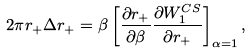Convert formula to latex. <formula><loc_0><loc_0><loc_500><loc_500>2 \pi r _ { + } \Delta r _ { + } = \beta \left [ { \frac { \partial { r _ { + } } } { \partial \beta } } { \frac { \partial { W _ { 1 } ^ { C S } } } { \partial r _ { + } } } \right ] _ { \alpha = 1 } ,</formula> 